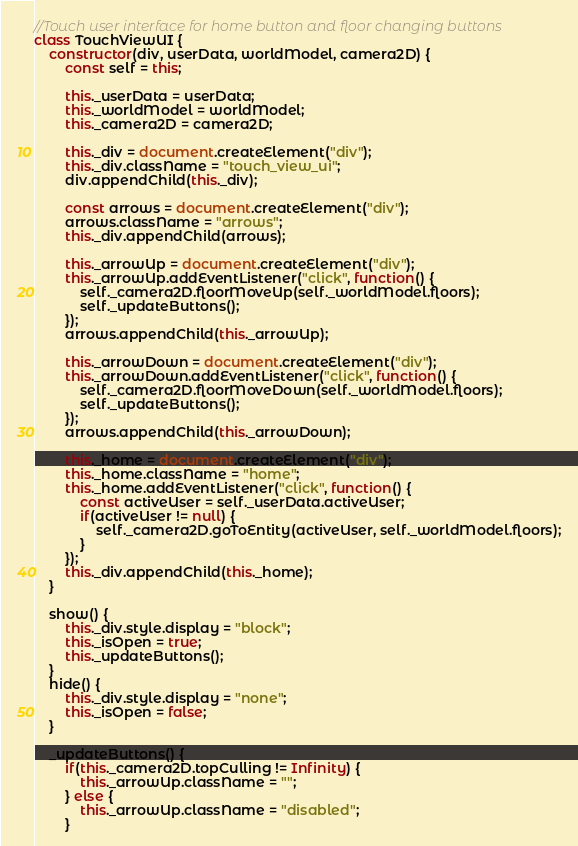Convert code to text. <code><loc_0><loc_0><loc_500><loc_500><_JavaScript_>
//Touch user interface for home button and floor changing buttons
class TouchViewUI {
	constructor(div, userData, worldModel, camera2D) {
		const self = this;

		this._userData = userData;
		this._worldModel = worldModel;
		this._camera2D = camera2D;

		this._div = document.createElement("div");
		this._div.className = "touch_view_ui";
		div.appendChild(this._div);

		const arrows = document.createElement("div");
		arrows.className = "arrows";
		this._div.appendChild(arrows);

		this._arrowUp = document.createElement("div");
		this._arrowUp.addEventListener("click", function() {
			self._camera2D.floorMoveUp(self._worldModel.floors);
			self._updateButtons();
		});
		arrows.appendChild(this._arrowUp);

		this._arrowDown = document.createElement("div");
		this._arrowDown.addEventListener("click", function() {
			self._camera2D.floorMoveDown(self._worldModel.floors);
			self._updateButtons();
		});
		arrows.appendChild(this._arrowDown);

		this._home = document.createElement("div");
		this._home.className = "home";
		this._home.addEventListener("click", function() {
			const activeUser = self._userData.activeUser;
			if(activeUser != null) {
				self._camera2D.goToEntity(activeUser, self._worldModel.floors);
			}
		});
		this._div.appendChild(this._home);
	}

	show() {
		this._div.style.display = "block";
		this._isOpen = true;
		this._updateButtons();
	}
	hide() {
		this._div.style.display = "none";
		this._isOpen = false;
	}

	_updateButtons() {
		if(this._camera2D.topCulling != Infinity) {
			this._arrowUp.className = "";
		} else {
			this._arrowUp.className = "disabled";
		}
</code> 